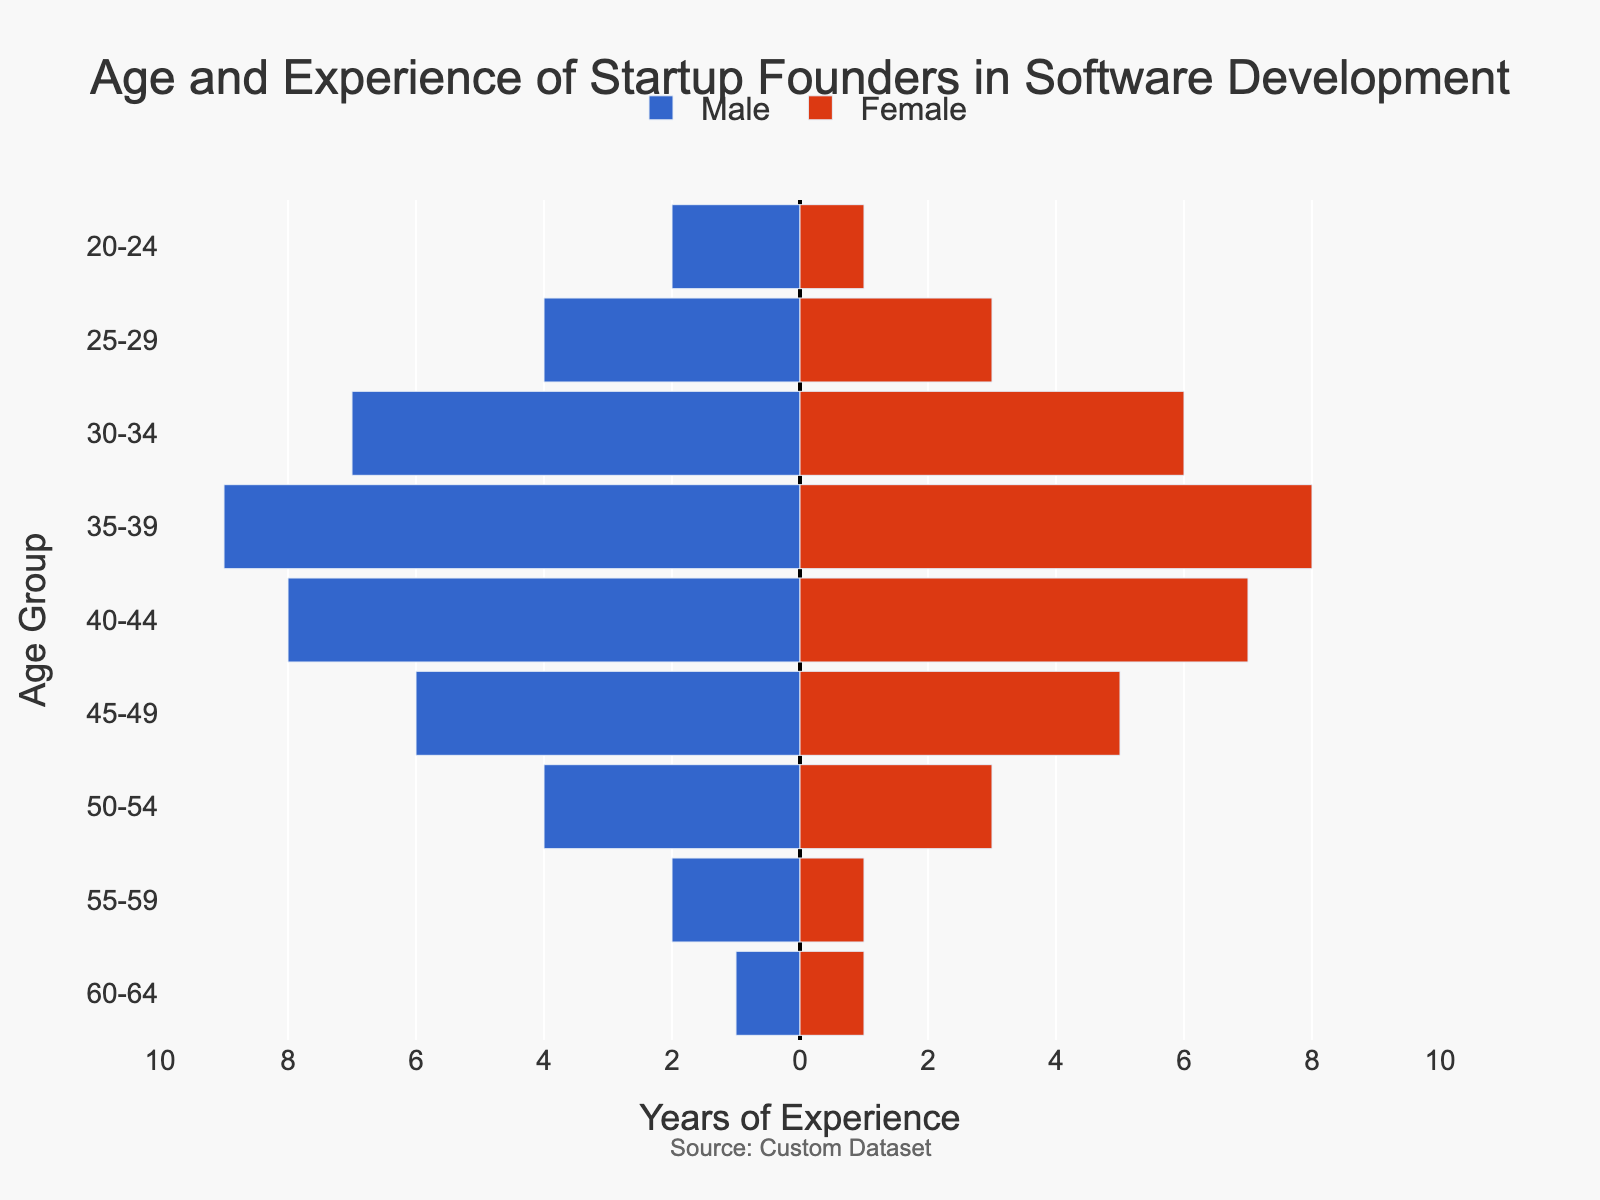What's the title of the figure? The title is located at the top of the figure, centering above the plot. It provides a brief description of the data depicted in the graph. The title is "Age and Experience of Startup Founders in Software Development".
Answer: Age and Experience of Startup Founders in Software Development What is the age group with the highest male experience? Look at the bars on the left side of the zero line, which represent male experience. Identify which bar is the longest. The longest bar falls in the "35-39" age group.
Answer: 35-39 How many years of experience do female founders aged 25-29 have in total? Look at the bar corresponding to "Female Experience" for the age group "25-29". The value is 3 years.
Answer: 3 years Which age group shows equal years of experience for male and female founders? Check each age group to find bars of equal length on both sides of the zero line. "60-64" is the only age group where male and female bars are equal, both showing 1 year of experience.
Answer: 60-64 What is the difference in years of experience between male and female founders aged 35-39? Find the values on the "35-39" bar for both male and female founders. The male founders have 9 years, and the female founders have 8 years, resulting in a difference of 1 year.
Answer: 1 year In which age group do female founders have more experience than male founders? Compare the length of the bars for male and female founders for each age group. Notice that in none of the age groups do female founders exceed male founders in experience.
Answer: None What is the total experience for male founders across all age groups? Sum the years of experience for male founders across all age groups: 2 + 4 + 7 + 9 + 8 + 6 + 4 + 2 + 1 = 43 years.
Answer: 43 years Which age group has the least experience for both male and female founders? Identify the shortest bars on both sides of the zero line. The "60-64" age group shows 1 year for both genders, which is the least experience.
Answer: 60-64 How does the gender experience gap change as age increases? Observe the difference in length between the male and female bars for each age group from the youngest to the oldest. The gap generally widens as age increases until the "35-39" age group, then starts to narrow again.
Answer: Widens then narrows In the age group "40-44", what is the combined experience of both male and female founders? Add the years of experience for male and female founders in this age group: 8 (male) + 7 (female) = 15 years.
Answer: 15 years 